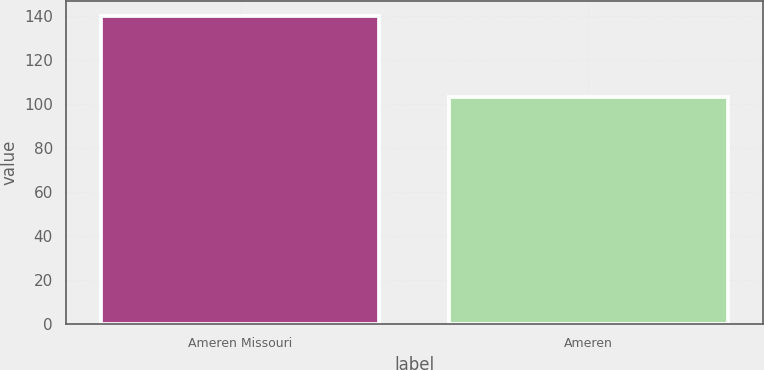<chart> <loc_0><loc_0><loc_500><loc_500><bar_chart><fcel>Ameren Missouri<fcel>Ameren<nl><fcel>140<fcel>103<nl></chart> 